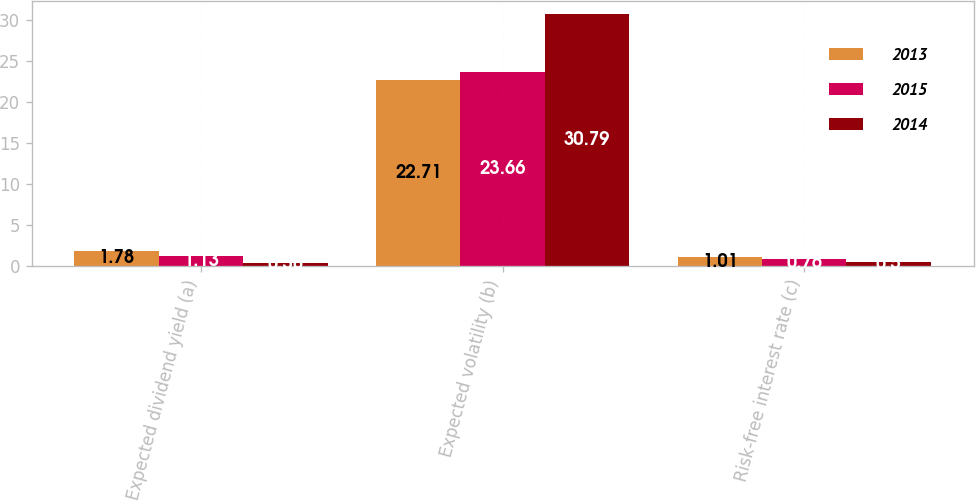Convert chart. <chart><loc_0><loc_0><loc_500><loc_500><stacked_bar_chart><ecel><fcel>Expected dividend yield (a)<fcel>Expected volatility (b)<fcel>Risk-free interest rate (c)<nl><fcel>2013<fcel>1.78<fcel>22.71<fcel>1.01<nl><fcel>2015<fcel>1.13<fcel>23.66<fcel>0.76<nl><fcel>2014<fcel>0.38<fcel>30.79<fcel>0.5<nl></chart> 